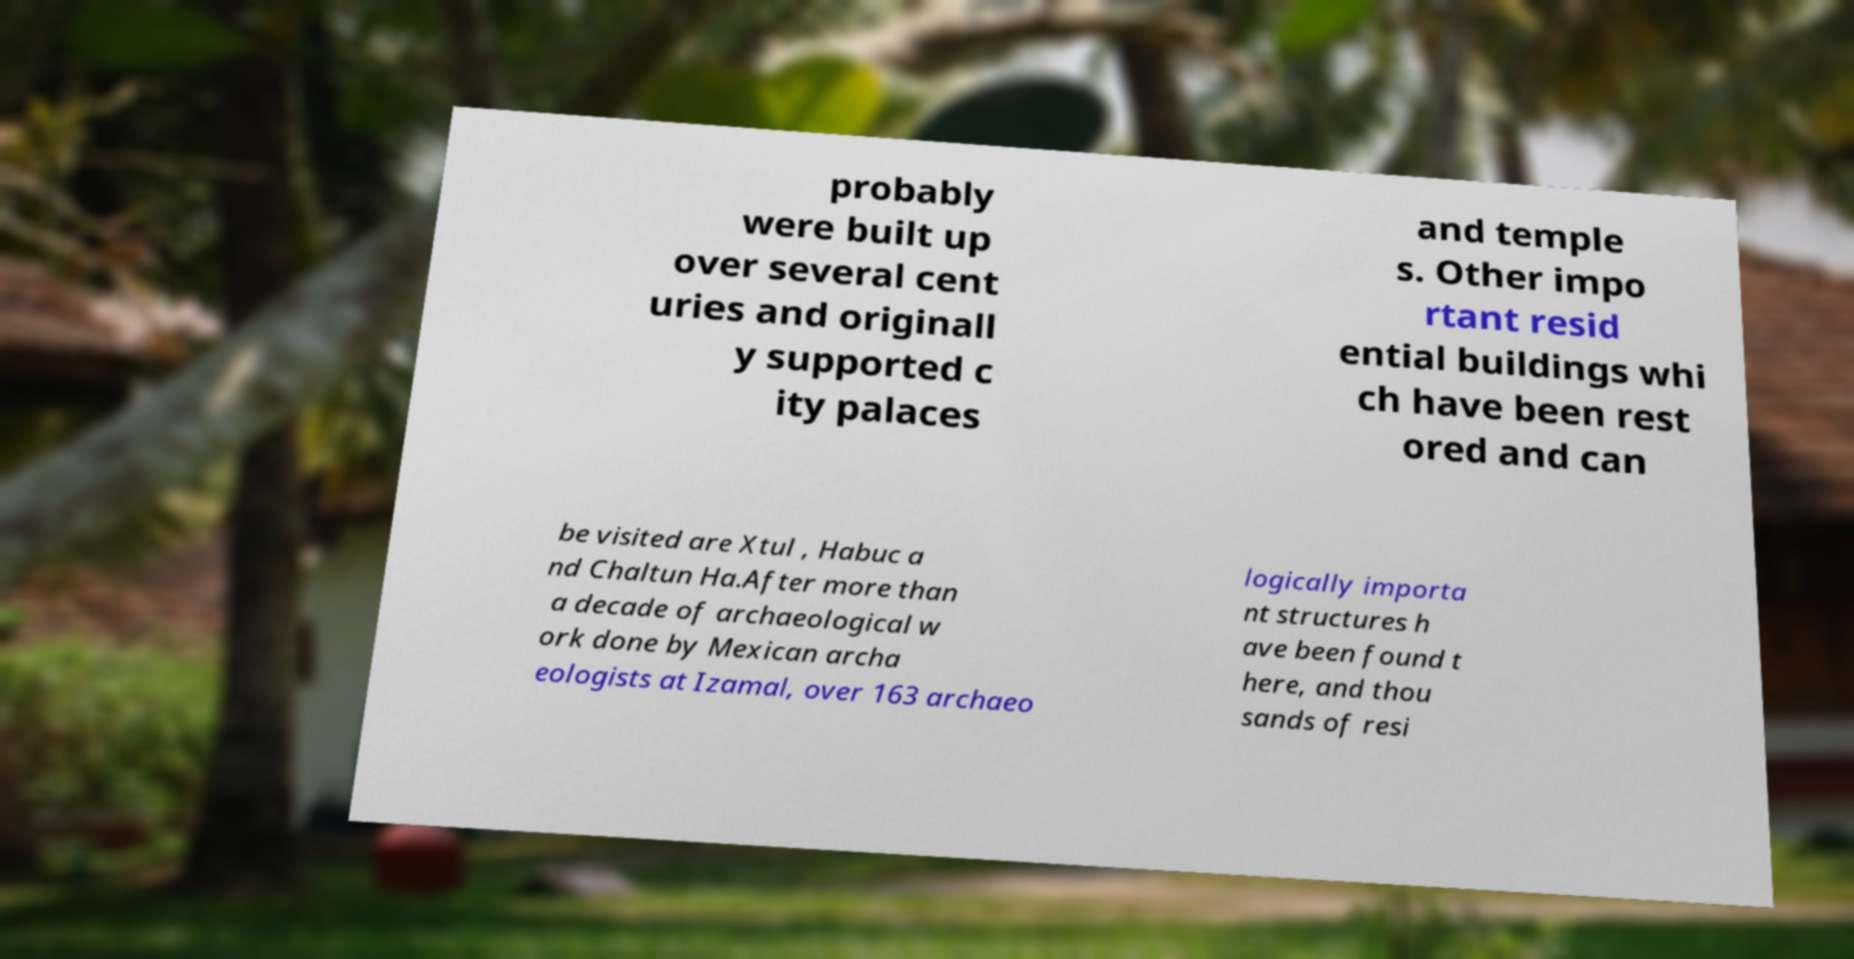Could you assist in decoding the text presented in this image and type it out clearly? probably were built up over several cent uries and originall y supported c ity palaces and temple s. Other impo rtant resid ential buildings whi ch have been rest ored and can be visited are Xtul , Habuc a nd Chaltun Ha.After more than a decade of archaeological w ork done by Mexican archa eologists at Izamal, over 163 archaeo logically importa nt structures h ave been found t here, and thou sands of resi 